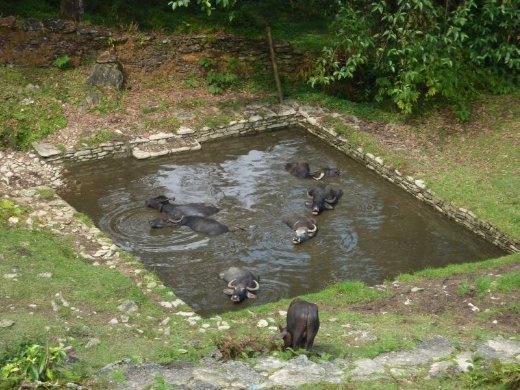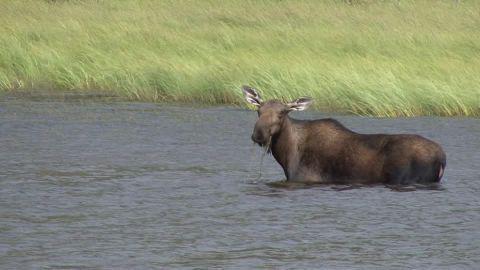The first image is the image on the left, the second image is the image on the right. Analyze the images presented: Is the assertion "The left image contains no more than one water buffalo swimming in water." valid? Answer yes or no. No. The first image is the image on the left, the second image is the image on the right. For the images shown, is this caption "The combined images contain no more than three water buffalo, all of them in water to their chins." true? Answer yes or no. No. 